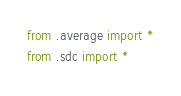Convert code to text. <code><loc_0><loc_0><loc_500><loc_500><_Python_>from .average import *
from .sdc import *</code> 